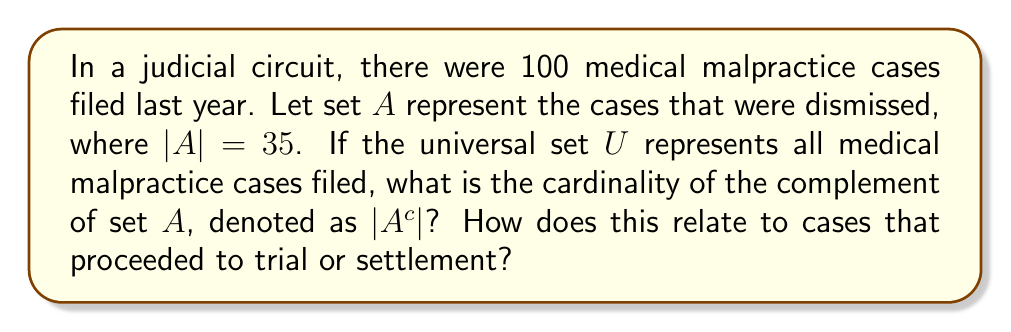Give your solution to this math problem. To solve this problem, we need to understand the concept of complement sets and how they relate to the universal set. Let's break it down step-by-step:

1) The universal set $U$ represents all medical malpractice cases filed last year.
   $|U| = 100$

2) Set $A$ represents the dismissed cases.
   $|A| = 35$

3) The complement of set $A$, denoted as $A^c$, represents all cases that were not dismissed.

4) A fundamental property of complement sets is:
   $|U| = |A| + |A^c|$

5) We can rearrange this equation to find $|A^c|$:
   $|A^c| = |U| - |A|$

6) Substituting the known values:
   $|A^c| = 100 - 35 = 65$

7) Therefore, 65 cases were not dismissed, meaning they either proceeded to trial or were settled out of court.

This analysis is crucial for a senior judge overseeing medical malpractice appeals, as it provides insight into the proportion of cases that progress beyond the dismissal stage and may require further judicial attention.
Answer: $|A^c| = 65$ 